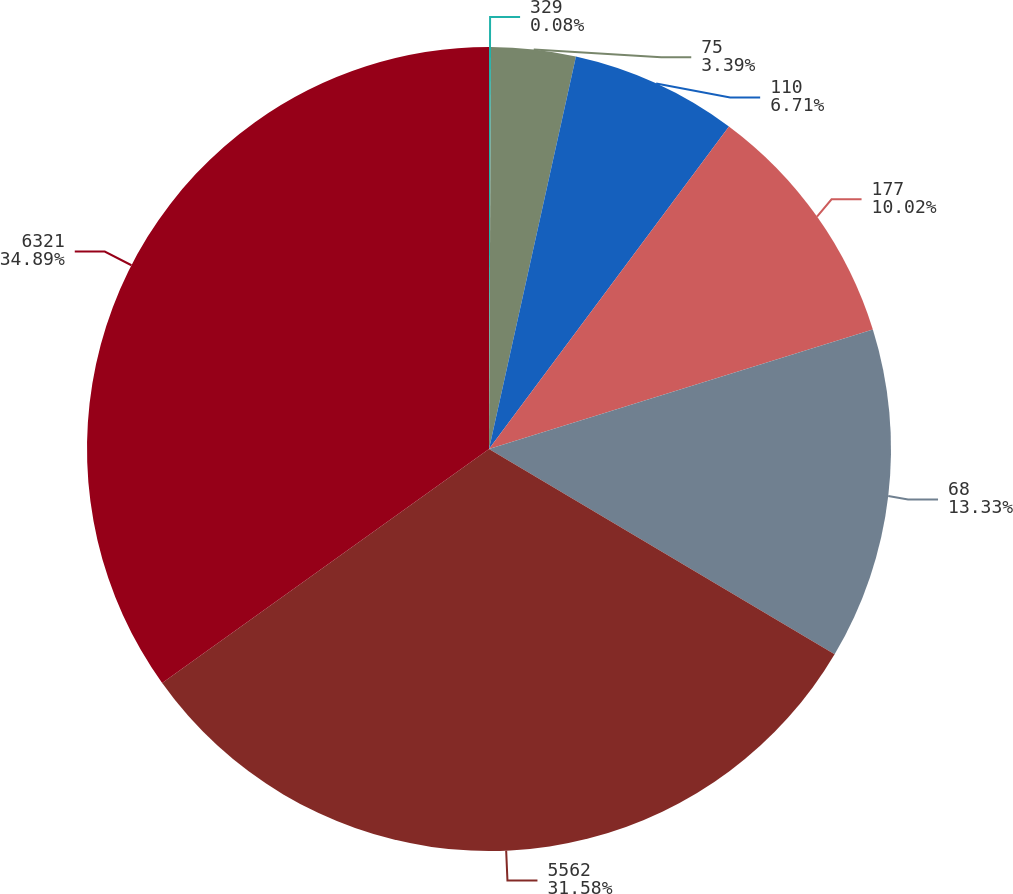Convert chart. <chart><loc_0><loc_0><loc_500><loc_500><pie_chart><fcel>329<fcel>75<fcel>110<fcel>177<fcel>68<fcel>5562<fcel>6321<nl><fcel>0.08%<fcel>3.39%<fcel>6.71%<fcel>10.02%<fcel>13.33%<fcel>31.58%<fcel>34.89%<nl></chart> 